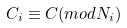<formula> <loc_0><loc_0><loc_500><loc_500>C _ { i } \equiv C ( m o d N _ { i } )</formula> 